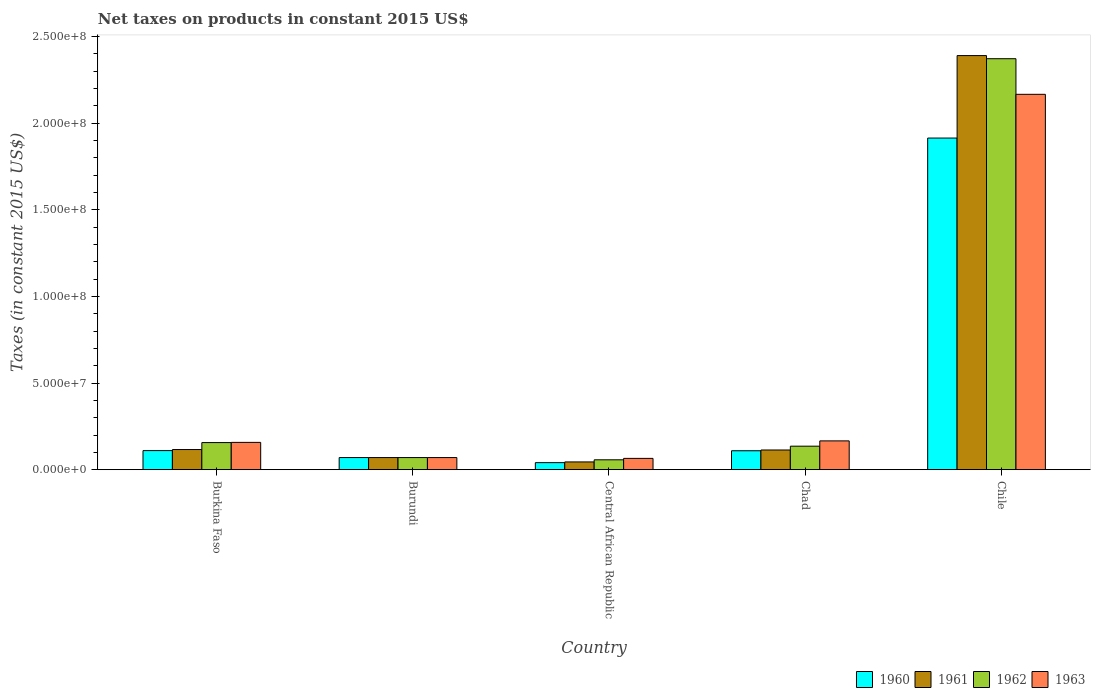How many different coloured bars are there?
Provide a short and direct response. 4. Are the number of bars on each tick of the X-axis equal?
Give a very brief answer. Yes. How many bars are there on the 3rd tick from the left?
Give a very brief answer. 4. How many bars are there on the 4th tick from the right?
Make the answer very short. 4. In how many cases, is the number of bars for a given country not equal to the number of legend labels?
Provide a succinct answer. 0. What is the net taxes on products in 1963 in Chad?
Offer a very short reply. 1.66e+07. Across all countries, what is the maximum net taxes on products in 1961?
Your answer should be very brief. 2.39e+08. Across all countries, what is the minimum net taxes on products in 1962?
Provide a succinct answer. 5.71e+06. In which country was the net taxes on products in 1963 minimum?
Give a very brief answer. Central African Republic. What is the total net taxes on products in 1963 in the graph?
Keep it short and to the point. 2.63e+08. What is the difference between the net taxes on products in 1963 in Burkina Faso and that in Central African Republic?
Offer a very short reply. 9.24e+06. What is the difference between the net taxes on products in 1963 in Chile and the net taxes on products in 1961 in Burkina Faso?
Make the answer very short. 2.05e+08. What is the average net taxes on products in 1961 per country?
Ensure brevity in your answer.  5.47e+07. What is the difference between the net taxes on products of/in 1961 and net taxes on products of/in 1962 in Chile?
Ensure brevity in your answer.  1.81e+06. In how many countries, is the net taxes on products in 1961 greater than 170000000 US$?
Your response must be concise. 1. What is the ratio of the net taxes on products in 1962 in Burkina Faso to that in Central African Republic?
Ensure brevity in your answer.  2.74. Is the net taxes on products in 1963 in Burkina Faso less than that in Chad?
Offer a very short reply. Yes. Is the difference between the net taxes on products in 1961 in Chad and Chile greater than the difference between the net taxes on products in 1962 in Chad and Chile?
Offer a terse response. No. What is the difference between the highest and the second highest net taxes on products in 1963?
Make the answer very short. 2.01e+08. What is the difference between the highest and the lowest net taxes on products in 1962?
Keep it short and to the point. 2.31e+08. In how many countries, is the net taxes on products in 1962 greater than the average net taxes on products in 1962 taken over all countries?
Your answer should be very brief. 1. Is the sum of the net taxes on products in 1961 in Central African Republic and Chad greater than the maximum net taxes on products in 1962 across all countries?
Give a very brief answer. No. What does the 2nd bar from the right in Central African Republic represents?
Provide a succinct answer. 1962. How many bars are there?
Your answer should be compact. 20. What is the difference between two consecutive major ticks on the Y-axis?
Provide a short and direct response. 5.00e+07. Does the graph contain any zero values?
Ensure brevity in your answer.  No. Does the graph contain grids?
Your answer should be very brief. No. What is the title of the graph?
Keep it short and to the point. Net taxes on products in constant 2015 US$. Does "1973" appear as one of the legend labels in the graph?
Provide a succinct answer. No. What is the label or title of the X-axis?
Ensure brevity in your answer.  Country. What is the label or title of the Y-axis?
Your response must be concise. Taxes (in constant 2015 US$). What is the Taxes (in constant 2015 US$) in 1960 in Burkina Faso?
Your answer should be very brief. 1.10e+07. What is the Taxes (in constant 2015 US$) in 1961 in Burkina Faso?
Your response must be concise. 1.16e+07. What is the Taxes (in constant 2015 US$) of 1962 in Burkina Faso?
Ensure brevity in your answer.  1.56e+07. What is the Taxes (in constant 2015 US$) in 1963 in Burkina Faso?
Make the answer very short. 1.58e+07. What is the Taxes (in constant 2015 US$) of 1961 in Burundi?
Provide a succinct answer. 7.00e+06. What is the Taxes (in constant 2015 US$) of 1963 in Burundi?
Offer a very short reply. 7.00e+06. What is the Taxes (in constant 2015 US$) in 1960 in Central African Republic?
Make the answer very short. 4.08e+06. What is the Taxes (in constant 2015 US$) of 1961 in Central African Republic?
Offer a terse response. 4.49e+06. What is the Taxes (in constant 2015 US$) of 1962 in Central African Republic?
Offer a terse response. 5.71e+06. What is the Taxes (in constant 2015 US$) in 1963 in Central African Republic?
Your answer should be very brief. 6.53e+06. What is the Taxes (in constant 2015 US$) of 1960 in Chad?
Your answer should be compact. 1.09e+07. What is the Taxes (in constant 2015 US$) of 1961 in Chad?
Ensure brevity in your answer.  1.14e+07. What is the Taxes (in constant 2015 US$) of 1962 in Chad?
Your response must be concise. 1.36e+07. What is the Taxes (in constant 2015 US$) in 1963 in Chad?
Provide a short and direct response. 1.66e+07. What is the Taxes (in constant 2015 US$) of 1960 in Chile?
Make the answer very short. 1.91e+08. What is the Taxes (in constant 2015 US$) of 1961 in Chile?
Offer a terse response. 2.39e+08. What is the Taxes (in constant 2015 US$) of 1962 in Chile?
Your answer should be compact. 2.37e+08. What is the Taxes (in constant 2015 US$) of 1963 in Chile?
Your answer should be very brief. 2.17e+08. Across all countries, what is the maximum Taxes (in constant 2015 US$) in 1960?
Ensure brevity in your answer.  1.91e+08. Across all countries, what is the maximum Taxes (in constant 2015 US$) of 1961?
Give a very brief answer. 2.39e+08. Across all countries, what is the maximum Taxes (in constant 2015 US$) in 1962?
Give a very brief answer. 2.37e+08. Across all countries, what is the maximum Taxes (in constant 2015 US$) in 1963?
Your answer should be very brief. 2.17e+08. Across all countries, what is the minimum Taxes (in constant 2015 US$) of 1960?
Provide a short and direct response. 4.08e+06. Across all countries, what is the minimum Taxes (in constant 2015 US$) in 1961?
Offer a very short reply. 4.49e+06. Across all countries, what is the minimum Taxes (in constant 2015 US$) in 1962?
Provide a short and direct response. 5.71e+06. Across all countries, what is the minimum Taxes (in constant 2015 US$) of 1963?
Make the answer very short. 6.53e+06. What is the total Taxes (in constant 2015 US$) of 1960 in the graph?
Keep it short and to the point. 2.24e+08. What is the total Taxes (in constant 2015 US$) in 1961 in the graph?
Keep it short and to the point. 2.73e+08. What is the total Taxes (in constant 2015 US$) in 1962 in the graph?
Your answer should be compact. 2.79e+08. What is the total Taxes (in constant 2015 US$) in 1963 in the graph?
Offer a terse response. 2.63e+08. What is the difference between the Taxes (in constant 2015 US$) of 1960 in Burkina Faso and that in Burundi?
Ensure brevity in your answer.  4.02e+06. What is the difference between the Taxes (in constant 2015 US$) in 1961 in Burkina Faso and that in Burundi?
Your response must be concise. 4.63e+06. What is the difference between the Taxes (in constant 2015 US$) in 1962 in Burkina Faso and that in Burundi?
Your answer should be compact. 8.65e+06. What is the difference between the Taxes (in constant 2015 US$) of 1963 in Burkina Faso and that in Burundi?
Provide a short and direct response. 8.77e+06. What is the difference between the Taxes (in constant 2015 US$) in 1960 in Burkina Faso and that in Central African Republic?
Make the answer very short. 6.94e+06. What is the difference between the Taxes (in constant 2015 US$) of 1961 in Burkina Faso and that in Central African Republic?
Keep it short and to the point. 7.15e+06. What is the difference between the Taxes (in constant 2015 US$) of 1962 in Burkina Faso and that in Central African Republic?
Provide a short and direct response. 9.93e+06. What is the difference between the Taxes (in constant 2015 US$) in 1963 in Burkina Faso and that in Central African Republic?
Make the answer very short. 9.24e+06. What is the difference between the Taxes (in constant 2015 US$) of 1960 in Burkina Faso and that in Chad?
Offer a terse response. 8.71e+04. What is the difference between the Taxes (in constant 2015 US$) in 1961 in Burkina Faso and that in Chad?
Give a very brief answer. 2.61e+05. What is the difference between the Taxes (in constant 2015 US$) of 1962 in Burkina Faso and that in Chad?
Make the answer very short. 2.08e+06. What is the difference between the Taxes (in constant 2015 US$) in 1963 in Burkina Faso and that in Chad?
Keep it short and to the point. -8.65e+05. What is the difference between the Taxes (in constant 2015 US$) in 1960 in Burkina Faso and that in Chile?
Your response must be concise. -1.80e+08. What is the difference between the Taxes (in constant 2015 US$) in 1961 in Burkina Faso and that in Chile?
Ensure brevity in your answer.  -2.27e+08. What is the difference between the Taxes (in constant 2015 US$) of 1962 in Burkina Faso and that in Chile?
Keep it short and to the point. -2.22e+08. What is the difference between the Taxes (in constant 2015 US$) of 1963 in Burkina Faso and that in Chile?
Make the answer very short. -2.01e+08. What is the difference between the Taxes (in constant 2015 US$) of 1960 in Burundi and that in Central African Republic?
Provide a succinct answer. 2.92e+06. What is the difference between the Taxes (in constant 2015 US$) of 1961 in Burundi and that in Central African Republic?
Keep it short and to the point. 2.51e+06. What is the difference between the Taxes (in constant 2015 US$) of 1962 in Burundi and that in Central African Republic?
Give a very brief answer. 1.29e+06. What is the difference between the Taxes (in constant 2015 US$) of 1963 in Burundi and that in Central African Republic?
Your answer should be compact. 4.70e+05. What is the difference between the Taxes (in constant 2015 US$) of 1960 in Burundi and that in Chad?
Give a very brief answer. -3.94e+06. What is the difference between the Taxes (in constant 2015 US$) in 1961 in Burundi and that in Chad?
Give a very brief answer. -4.37e+06. What is the difference between the Taxes (in constant 2015 US$) of 1962 in Burundi and that in Chad?
Provide a succinct answer. -6.57e+06. What is the difference between the Taxes (in constant 2015 US$) of 1963 in Burundi and that in Chad?
Offer a terse response. -9.63e+06. What is the difference between the Taxes (in constant 2015 US$) of 1960 in Burundi and that in Chile?
Offer a terse response. -1.84e+08. What is the difference between the Taxes (in constant 2015 US$) in 1961 in Burundi and that in Chile?
Offer a very short reply. -2.32e+08. What is the difference between the Taxes (in constant 2015 US$) in 1962 in Burundi and that in Chile?
Offer a terse response. -2.30e+08. What is the difference between the Taxes (in constant 2015 US$) of 1963 in Burundi and that in Chile?
Provide a succinct answer. -2.10e+08. What is the difference between the Taxes (in constant 2015 US$) of 1960 in Central African Republic and that in Chad?
Offer a terse response. -6.86e+06. What is the difference between the Taxes (in constant 2015 US$) of 1961 in Central African Republic and that in Chad?
Make the answer very short. -6.88e+06. What is the difference between the Taxes (in constant 2015 US$) of 1962 in Central African Republic and that in Chad?
Keep it short and to the point. -7.86e+06. What is the difference between the Taxes (in constant 2015 US$) in 1963 in Central African Republic and that in Chad?
Provide a short and direct response. -1.01e+07. What is the difference between the Taxes (in constant 2015 US$) of 1960 in Central African Republic and that in Chile?
Give a very brief answer. -1.87e+08. What is the difference between the Taxes (in constant 2015 US$) of 1961 in Central African Republic and that in Chile?
Give a very brief answer. -2.35e+08. What is the difference between the Taxes (in constant 2015 US$) in 1962 in Central African Republic and that in Chile?
Your answer should be very brief. -2.31e+08. What is the difference between the Taxes (in constant 2015 US$) of 1963 in Central African Republic and that in Chile?
Your answer should be compact. -2.10e+08. What is the difference between the Taxes (in constant 2015 US$) in 1960 in Chad and that in Chile?
Make the answer very short. -1.80e+08. What is the difference between the Taxes (in constant 2015 US$) in 1961 in Chad and that in Chile?
Keep it short and to the point. -2.28e+08. What is the difference between the Taxes (in constant 2015 US$) of 1962 in Chad and that in Chile?
Give a very brief answer. -2.24e+08. What is the difference between the Taxes (in constant 2015 US$) of 1963 in Chad and that in Chile?
Your response must be concise. -2.00e+08. What is the difference between the Taxes (in constant 2015 US$) of 1960 in Burkina Faso and the Taxes (in constant 2015 US$) of 1961 in Burundi?
Your answer should be very brief. 4.02e+06. What is the difference between the Taxes (in constant 2015 US$) of 1960 in Burkina Faso and the Taxes (in constant 2015 US$) of 1962 in Burundi?
Make the answer very short. 4.02e+06. What is the difference between the Taxes (in constant 2015 US$) of 1960 in Burkina Faso and the Taxes (in constant 2015 US$) of 1963 in Burundi?
Offer a very short reply. 4.02e+06. What is the difference between the Taxes (in constant 2015 US$) in 1961 in Burkina Faso and the Taxes (in constant 2015 US$) in 1962 in Burundi?
Give a very brief answer. 4.63e+06. What is the difference between the Taxes (in constant 2015 US$) of 1961 in Burkina Faso and the Taxes (in constant 2015 US$) of 1963 in Burundi?
Keep it short and to the point. 4.63e+06. What is the difference between the Taxes (in constant 2015 US$) in 1962 in Burkina Faso and the Taxes (in constant 2015 US$) in 1963 in Burundi?
Your answer should be compact. 8.65e+06. What is the difference between the Taxes (in constant 2015 US$) of 1960 in Burkina Faso and the Taxes (in constant 2015 US$) of 1961 in Central African Republic?
Keep it short and to the point. 6.54e+06. What is the difference between the Taxes (in constant 2015 US$) in 1960 in Burkina Faso and the Taxes (in constant 2015 US$) in 1962 in Central African Republic?
Your answer should be very brief. 5.31e+06. What is the difference between the Taxes (in constant 2015 US$) of 1960 in Burkina Faso and the Taxes (in constant 2015 US$) of 1963 in Central African Republic?
Give a very brief answer. 4.49e+06. What is the difference between the Taxes (in constant 2015 US$) in 1961 in Burkina Faso and the Taxes (in constant 2015 US$) in 1962 in Central African Republic?
Keep it short and to the point. 5.92e+06. What is the difference between the Taxes (in constant 2015 US$) in 1961 in Burkina Faso and the Taxes (in constant 2015 US$) in 1963 in Central African Republic?
Ensure brevity in your answer.  5.10e+06. What is the difference between the Taxes (in constant 2015 US$) of 1962 in Burkina Faso and the Taxes (in constant 2015 US$) of 1963 in Central African Republic?
Provide a succinct answer. 9.12e+06. What is the difference between the Taxes (in constant 2015 US$) in 1960 in Burkina Faso and the Taxes (in constant 2015 US$) in 1961 in Chad?
Provide a succinct answer. -3.47e+05. What is the difference between the Taxes (in constant 2015 US$) in 1960 in Burkina Faso and the Taxes (in constant 2015 US$) in 1962 in Chad?
Your answer should be compact. -2.55e+06. What is the difference between the Taxes (in constant 2015 US$) of 1960 in Burkina Faso and the Taxes (in constant 2015 US$) of 1963 in Chad?
Give a very brief answer. -5.61e+06. What is the difference between the Taxes (in constant 2015 US$) in 1961 in Burkina Faso and the Taxes (in constant 2015 US$) in 1962 in Chad?
Offer a very short reply. -1.94e+06. What is the difference between the Taxes (in constant 2015 US$) in 1961 in Burkina Faso and the Taxes (in constant 2015 US$) in 1963 in Chad?
Provide a succinct answer. -5.00e+06. What is the difference between the Taxes (in constant 2015 US$) of 1962 in Burkina Faso and the Taxes (in constant 2015 US$) of 1963 in Chad?
Make the answer very short. -9.87e+05. What is the difference between the Taxes (in constant 2015 US$) in 1960 in Burkina Faso and the Taxes (in constant 2015 US$) in 1961 in Chile?
Offer a terse response. -2.28e+08. What is the difference between the Taxes (in constant 2015 US$) in 1960 in Burkina Faso and the Taxes (in constant 2015 US$) in 1962 in Chile?
Give a very brief answer. -2.26e+08. What is the difference between the Taxes (in constant 2015 US$) in 1960 in Burkina Faso and the Taxes (in constant 2015 US$) in 1963 in Chile?
Your response must be concise. -2.06e+08. What is the difference between the Taxes (in constant 2015 US$) of 1961 in Burkina Faso and the Taxes (in constant 2015 US$) of 1962 in Chile?
Provide a succinct answer. -2.26e+08. What is the difference between the Taxes (in constant 2015 US$) of 1961 in Burkina Faso and the Taxes (in constant 2015 US$) of 1963 in Chile?
Give a very brief answer. -2.05e+08. What is the difference between the Taxes (in constant 2015 US$) in 1962 in Burkina Faso and the Taxes (in constant 2015 US$) in 1963 in Chile?
Your answer should be very brief. -2.01e+08. What is the difference between the Taxes (in constant 2015 US$) of 1960 in Burundi and the Taxes (in constant 2015 US$) of 1961 in Central African Republic?
Give a very brief answer. 2.51e+06. What is the difference between the Taxes (in constant 2015 US$) of 1960 in Burundi and the Taxes (in constant 2015 US$) of 1962 in Central African Republic?
Keep it short and to the point. 1.29e+06. What is the difference between the Taxes (in constant 2015 US$) of 1960 in Burundi and the Taxes (in constant 2015 US$) of 1963 in Central African Republic?
Ensure brevity in your answer.  4.70e+05. What is the difference between the Taxes (in constant 2015 US$) in 1961 in Burundi and the Taxes (in constant 2015 US$) in 1962 in Central African Republic?
Your answer should be compact. 1.29e+06. What is the difference between the Taxes (in constant 2015 US$) of 1961 in Burundi and the Taxes (in constant 2015 US$) of 1963 in Central African Republic?
Offer a very short reply. 4.70e+05. What is the difference between the Taxes (in constant 2015 US$) in 1962 in Burundi and the Taxes (in constant 2015 US$) in 1963 in Central African Republic?
Provide a succinct answer. 4.70e+05. What is the difference between the Taxes (in constant 2015 US$) in 1960 in Burundi and the Taxes (in constant 2015 US$) in 1961 in Chad?
Provide a short and direct response. -4.37e+06. What is the difference between the Taxes (in constant 2015 US$) of 1960 in Burundi and the Taxes (in constant 2015 US$) of 1962 in Chad?
Keep it short and to the point. -6.57e+06. What is the difference between the Taxes (in constant 2015 US$) of 1960 in Burundi and the Taxes (in constant 2015 US$) of 1963 in Chad?
Provide a succinct answer. -9.63e+06. What is the difference between the Taxes (in constant 2015 US$) in 1961 in Burundi and the Taxes (in constant 2015 US$) in 1962 in Chad?
Make the answer very short. -6.57e+06. What is the difference between the Taxes (in constant 2015 US$) in 1961 in Burundi and the Taxes (in constant 2015 US$) in 1963 in Chad?
Your response must be concise. -9.63e+06. What is the difference between the Taxes (in constant 2015 US$) in 1962 in Burundi and the Taxes (in constant 2015 US$) in 1963 in Chad?
Your answer should be very brief. -9.63e+06. What is the difference between the Taxes (in constant 2015 US$) in 1960 in Burundi and the Taxes (in constant 2015 US$) in 1961 in Chile?
Ensure brevity in your answer.  -2.32e+08. What is the difference between the Taxes (in constant 2015 US$) of 1960 in Burundi and the Taxes (in constant 2015 US$) of 1962 in Chile?
Provide a short and direct response. -2.30e+08. What is the difference between the Taxes (in constant 2015 US$) in 1960 in Burundi and the Taxes (in constant 2015 US$) in 1963 in Chile?
Your answer should be compact. -2.10e+08. What is the difference between the Taxes (in constant 2015 US$) of 1961 in Burundi and the Taxes (in constant 2015 US$) of 1962 in Chile?
Your answer should be very brief. -2.30e+08. What is the difference between the Taxes (in constant 2015 US$) of 1961 in Burundi and the Taxes (in constant 2015 US$) of 1963 in Chile?
Make the answer very short. -2.10e+08. What is the difference between the Taxes (in constant 2015 US$) of 1962 in Burundi and the Taxes (in constant 2015 US$) of 1963 in Chile?
Your response must be concise. -2.10e+08. What is the difference between the Taxes (in constant 2015 US$) in 1960 in Central African Republic and the Taxes (in constant 2015 US$) in 1961 in Chad?
Give a very brief answer. -7.29e+06. What is the difference between the Taxes (in constant 2015 US$) of 1960 in Central African Republic and the Taxes (in constant 2015 US$) of 1962 in Chad?
Make the answer very short. -9.49e+06. What is the difference between the Taxes (in constant 2015 US$) in 1960 in Central African Republic and the Taxes (in constant 2015 US$) in 1963 in Chad?
Offer a terse response. -1.26e+07. What is the difference between the Taxes (in constant 2015 US$) of 1961 in Central African Republic and the Taxes (in constant 2015 US$) of 1962 in Chad?
Give a very brief answer. -9.08e+06. What is the difference between the Taxes (in constant 2015 US$) in 1961 in Central African Republic and the Taxes (in constant 2015 US$) in 1963 in Chad?
Give a very brief answer. -1.21e+07. What is the difference between the Taxes (in constant 2015 US$) of 1962 in Central African Republic and the Taxes (in constant 2015 US$) of 1963 in Chad?
Provide a succinct answer. -1.09e+07. What is the difference between the Taxes (in constant 2015 US$) of 1960 in Central African Republic and the Taxes (in constant 2015 US$) of 1961 in Chile?
Provide a short and direct response. -2.35e+08. What is the difference between the Taxes (in constant 2015 US$) of 1960 in Central African Republic and the Taxes (in constant 2015 US$) of 1962 in Chile?
Give a very brief answer. -2.33e+08. What is the difference between the Taxes (in constant 2015 US$) in 1960 in Central African Republic and the Taxes (in constant 2015 US$) in 1963 in Chile?
Offer a very short reply. -2.13e+08. What is the difference between the Taxes (in constant 2015 US$) of 1961 in Central African Republic and the Taxes (in constant 2015 US$) of 1962 in Chile?
Make the answer very short. -2.33e+08. What is the difference between the Taxes (in constant 2015 US$) of 1961 in Central African Republic and the Taxes (in constant 2015 US$) of 1963 in Chile?
Your response must be concise. -2.12e+08. What is the difference between the Taxes (in constant 2015 US$) in 1962 in Central African Republic and the Taxes (in constant 2015 US$) in 1963 in Chile?
Ensure brevity in your answer.  -2.11e+08. What is the difference between the Taxes (in constant 2015 US$) in 1960 in Chad and the Taxes (in constant 2015 US$) in 1961 in Chile?
Your answer should be very brief. -2.28e+08. What is the difference between the Taxes (in constant 2015 US$) of 1960 in Chad and the Taxes (in constant 2015 US$) of 1962 in Chile?
Ensure brevity in your answer.  -2.26e+08. What is the difference between the Taxes (in constant 2015 US$) in 1960 in Chad and the Taxes (in constant 2015 US$) in 1963 in Chile?
Make the answer very short. -2.06e+08. What is the difference between the Taxes (in constant 2015 US$) in 1961 in Chad and the Taxes (in constant 2015 US$) in 1962 in Chile?
Make the answer very short. -2.26e+08. What is the difference between the Taxes (in constant 2015 US$) of 1961 in Chad and the Taxes (in constant 2015 US$) of 1963 in Chile?
Offer a very short reply. -2.05e+08. What is the difference between the Taxes (in constant 2015 US$) in 1962 in Chad and the Taxes (in constant 2015 US$) in 1963 in Chile?
Your response must be concise. -2.03e+08. What is the average Taxes (in constant 2015 US$) of 1960 per country?
Your answer should be very brief. 4.49e+07. What is the average Taxes (in constant 2015 US$) of 1961 per country?
Provide a succinct answer. 5.47e+07. What is the average Taxes (in constant 2015 US$) of 1962 per country?
Your response must be concise. 5.58e+07. What is the average Taxes (in constant 2015 US$) of 1963 per country?
Your response must be concise. 5.25e+07. What is the difference between the Taxes (in constant 2015 US$) in 1960 and Taxes (in constant 2015 US$) in 1961 in Burkina Faso?
Your response must be concise. -6.08e+05. What is the difference between the Taxes (in constant 2015 US$) in 1960 and Taxes (in constant 2015 US$) in 1962 in Burkina Faso?
Keep it short and to the point. -4.62e+06. What is the difference between the Taxes (in constant 2015 US$) of 1960 and Taxes (in constant 2015 US$) of 1963 in Burkina Faso?
Keep it short and to the point. -4.75e+06. What is the difference between the Taxes (in constant 2015 US$) in 1961 and Taxes (in constant 2015 US$) in 1962 in Burkina Faso?
Keep it short and to the point. -4.02e+06. What is the difference between the Taxes (in constant 2015 US$) in 1961 and Taxes (in constant 2015 US$) in 1963 in Burkina Faso?
Offer a very short reply. -4.14e+06. What is the difference between the Taxes (in constant 2015 US$) in 1962 and Taxes (in constant 2015 US$) in 1963 in Burkina Faso?
Make the answer very short. -1.22e+05. What is the difference between the Taxes (in constant 2015 US$) in 1960 and Taxes (in constant 2015 US$) in 1961 in Burundi?
Your response must be concise. 0. What is the difference between the Taxes (in constant 2015 US$) of 1960 and Taxes (in constant 2015 US$) of 1962 in Burundi?
Your answer should be compact. 0. What is the difference between the Taxes (in constant 2015 US$) in 1961 and Taxes (in constant 2015 US$) in 1962 in Burundi?
Keep it short and to the point. 0. What is the difference between the Taxes (in constant 2015 US$) in 1961 and Taxes (in constant 2015 US$) in 1963 in Burundi?
Your answer should be compact. 0. What is the difference between the Taxes (in constant 2015 US$) of 1962 and Taxes (in constant 2015 US$) of 1963 in Burundi?
Provide a short and direct response. 0. What is the difference between the Taxes (in constant 2015 US$) of 1960 and Taxes (in constant 2015 US$) of 1961 in Central African Republic?
Provide a succinct answer. -4.07e+05. What is the difference between the Taxes (in constant 2015 US$) in 1960 and Taxes (in constant 2015 US$) in 1962 in Central African Republic?
Give a very brief answer. -1.64e+06. What is the difference between the Taxes (in constant 2015 US$) in 1960 and Taxes (in constant 2015 US$) in 1963 in Central African Republic?
Ensure brevity in your answer.  -2.45e+06. What is the difference between the Taxes (in constant 2015 US$) of 1961 and Taxes (in constant 2015 US$) of 1962 in Central African Republic?
Provide a short and direct response. -1.23e+06. What is the difference between the Taxes (in constant 2015 US$) of 1961 and Taxes (in constant 2015 US$) of 1963 in Central African Republic?
Your answer should be compact. -2.05e+06. What is the difference between the Taxes (in constant 2015 US$) of 1962 and Taxes (in constant 2015 US$) of 1963 in Central African Republic?
Offer a very short reply. -8.16e+05. What is the difference between the Taxes (in constant 2015 US$) in 1960 and Taxes (in constant 2015 US$) in 1961 in Chad?
Your response must be concise. -4.34e+05. What is the difference between the Taxes (in constant 2015 US$) in 1960 and Taxes (in constant 2015 US$) in 1962 in Chad?
Ensure brevity in your answer.  -2.63e+06. What is the difference between the Taxes (in constant 2015 US$) of 1960 and Taxes (in constant 2015 US$) of 1963 in Chad?
Give a very brief answer. -5.70e+06. What is the difference between the Taxes (in constant 2015 US$) of 1961 and Taxes (in constant 2015 US$) of 1962 in Chad?
Keep it short and to the point. -2.20e+06. What is the difference between the Taxes (in constant 2015 US$) in 1961 and Taxes (in constant 2015 US$) in 1963 in Chad?
Offer a very short reply. -5.26e+06. What is the difference between the Taxes (in constant 2015 US$) in 1962 and Taxes (in constant 2015 US$) in 1963 in Chad?
Make the answer very short. -3.06e+06. What is the difference between the Taxes (in constant 2015 US$) of 1960 and Taxes (in constant 2015 US$) of 1961 in Chile?
Keep it short and to the point. -4.76e+07. What is the difference between the Taxes (in constant 2015 US$) in 1960 and Taxes (in constant 2015 US$) in 1962 in Chile?
Make the answer very short. -4.58e+07. What is the difference between the Taxes (in constant 2015 US$) in 1960 and Taxes (in constant 2015 US$) in 1963 in Chile?
Your answer should be very brief. -2.52e+07. What is the difference between the Taxes (in constant 2015 US$) in 1961 and Taxes (in constant 2015 US$) in 1962 in Chile?
Make the answer very short. 1.81e+06. What is the difference between the Taxes (in constant 2015 US$) of 1961 and Taxes (in constant 2015 US$) of 1963 in Chile?
Ensure brevity in your answer.  2.24e+07. What is the difference between the Taxes (in constant 2015 US$) in 1962 and Taxes (in constant 2015 US$) in 1963 in Chile?
Keep it short and to the point. 2.06e+07. What is the ratio of the Taxes (in constant 2015 US$) of 1960 in Burkina Faso to that in Burundi?
Ensure brevity in your answer.  1.57. What is the ratio of the Taxes (in constant 2015 US$) in 1961 in Burkina Faso to that in Burundi?
Your response must be concise. 1.66. What is the ratio of the Taxes (in constant 2015 US$) of 1962 in Burkina Faso to that in Burundi?
Offer a terse response. 2.24. What is the ratio of the Taxes (in constant 2015 US$) of 1963 in Burkina Faso to that in Burundi?
Make the answer very short. 2.25. What is the ratio of the Taxes (in constant 2015 US$) of 1960 in Burkina Faso to that in Central African Republic?
Offer a terse response. 2.7. What is the ratio of the Taxes (in constant 2015 US$) in 1961 in Burkina Faso to that in Central African Republic?
Make the answer very short. 2.59. What is the ratio of the Taxes (in constant 2015 US$) in 1962 in Burkina Faso to that in Central African Republic?
Your answer should be very brief. 2.74. What is the ratio of the Taxes (in constant 2015 US$) of 1963 in Burkina Faso to that in Central African Republic?
Your answer should be very brief. 2.41. What is the ratio of the Taxes (in constant 2015 US$) in 1960 in Burkina Faso to that in Chad?
Provide a short and direct response. 1.01. What is the ratio of the Taxes (in constant 2015 US$) in 1961 in Burkina Faso to that in Chad?
Your answer should be compact. 1.02. What is the ratio of the Taxes (in constant 2015 US$) of 1962 in Burkina Faso to that in Chad?
Give a very brief answer. 1.15. What is the ratio of the Taxes (in constant 2015 US$) in 1963 in Burkina Faso to that in Chad?
Your answer should be very brief. 0.95. What is the ratio of the Taxes (in constant 2015 US$) of 1960 in Burkina Faso to that in Chile?
Ensure brevity in your answer.  0.06. What is the ratio of the Taxes (in constant 2015 US$) of 1961 in Burkina Faso to that in Chile?
Keep it short and to the point. 0.05. What is the ratio of the Taxes (in constant 2015 US$) of 1962 in Burkina Faso to that in Chile?
Make the answer very short. 0.07. What is the ratio of the Taxes (in constant 2015 US$) in 1963 in Burkina Faso to that in Chile?
Your answer should be compact. 0.07. What is the ratio of the Taxes (in constant 2015 US$) of 1960 in Burundi to that in Central African Republic?
Your answer should be compact. 1.72. What is the ratio of the Taxes (in constant 2015 US$) of 1961 in Burundi to that in Central African Republic?
Ensure brevity in your answer.  1.56. What is the ratio of the Taxes (in constant 2015 US$) of 1962 in Burundi to that in Central African Republic?
Make the answer very short. 1.23. What is the ratio of the Taxes (in constant 2015 US$) in 1963 in Burundi to that in Central African Republic?
Provide a short and direct response. 1.07. What is the ratio of the Taxes (in constant 2015 US$) in 1960 in Burundi to that in Chad?
Your answer should be compact. 0.64. What is the ratio of the Taxes (in constant 2015 US$) of 1961 in Burundi to that in Chad?
Offer a terse response. 0.62. What is the ratio of the Taxes (in constant 2015 US$) of 1962 in Burundi to that in Chad?
Your answer should be very brief. 0.52. What is the ratio of the Taxes (in constant 2015 US$) of 1963 in Burundi to that in Chad?
Your answer should be compact. 0.42. What is the ratio of the Taxes (in constant 2015 US$) in 1960 in Burundi to that in Chile?
Keep it short and to the point. 0.04. What is the ratio of the Taxes (in constant 2015 US$) of 1961 in Burundi to that in Chile?
Make the answer very short. 0.03. What is the ratio of the Taxes (in constant 2015 US$) of 1962 in Burundi to that in Chile?
Offer a very short reply. 0.03. What is the ratio of the Taxes (in constant 2015 US$) in 1963 in Burundi to that in Chile?
Your answer should be compact. 0.03. What is the ratio of the Taxes (in constant 2015 US$) in 1960 in Central African Republic to that in Chad?
Your answer should be compact. 0.37. What is the ratio of the Taxes (in constant 2015 US$) of 1961 in Central African Republic to that in Chad?
Keep it short and to the point. 0.39. What is the ratio of the Taxes (in constant 2015 US$) of 1962 in Central African Republic to that in Chad?
Your answer should be very brief. 0.42. What is the ratio of the Taxes (in constant 2015 US$) of 1963 in Central African Republic to that in Chad?
Give a very brief answer. 0.39. What is the ratio of the Taxes (in constant 2015 US$) in 1960 in Central African Republic to that in Chile?
Offer a terse response. 0.02. What is the ratio of the Taxes (in constant 2015 US$) of 1961 in Central African Republic to that in Chile?
Provide a succinct answer. 0.02. What is the ratio of the Taxes (in constant 2015 US$) in 1962 in Central African Republic to that in Chile?
Ensure brevity in your answer.  0.02. What is the ratio of the Taxes (in constant 2015 US$) of 1963 in Central African Republic to that in Chile?
Provide a succinct answer. 0.03. What is the ratio of the Taxes (in constant 2015 US$) of 1960 in Chad to that in Chile?
Keep it short and to the point. 0.06. What is the ratio of the Taxes (in constant 2015 US$) of 1961 in Chad to that in Chile?
Make the answer very short. 0.05. What is the ratio of the Taxes (in constant 2015 US$) of 1962 in Chad to that in Chile?
Ensure brevity in your answer.  0.06. What is the ratio of the Taxes (in constant 2015 US$) in 1963 in Chad to that in Chile?
Make the answer very short. 0.08. What is the difference between the highest and the second highest Taxes (in constant 2015 US$) in 1960?
Provide a short and direct response. 1.80e+08. What is the difference between the highest and the second highest Taxes (in constant 2015 US$) in 1961?
Your response must be concise. 2.27e+08. What is the difference between the highest and the second highest Taxes (in constant 2015 US$) of 1962?
Your answer should be very brief. 2.22e+08. What is the difference between the highest and the second highest Taxes (in constant 2015 US$) of 1963?
Keep it short and to the point. 2.00e+08. What is the difference between the highest and the lowest Taxes (in constant 2015 US$) in 1960?
Provide a succinct answer. 1.87e+08. What is the difference between the highest and the lowest Taxes (in constant 2015 US$) of 1961?
Provide a short and direct response. 2.35e+08. What is the difference between the highest and the lowest Taxes (in constant 2015 US$) of 1962?
Make the answer very short. 2.31e+08. What is the difference between the highest and the lowest Taxes (in constant 2015 US$) of 1963?
Offer a terse response. 2.10e+08. 